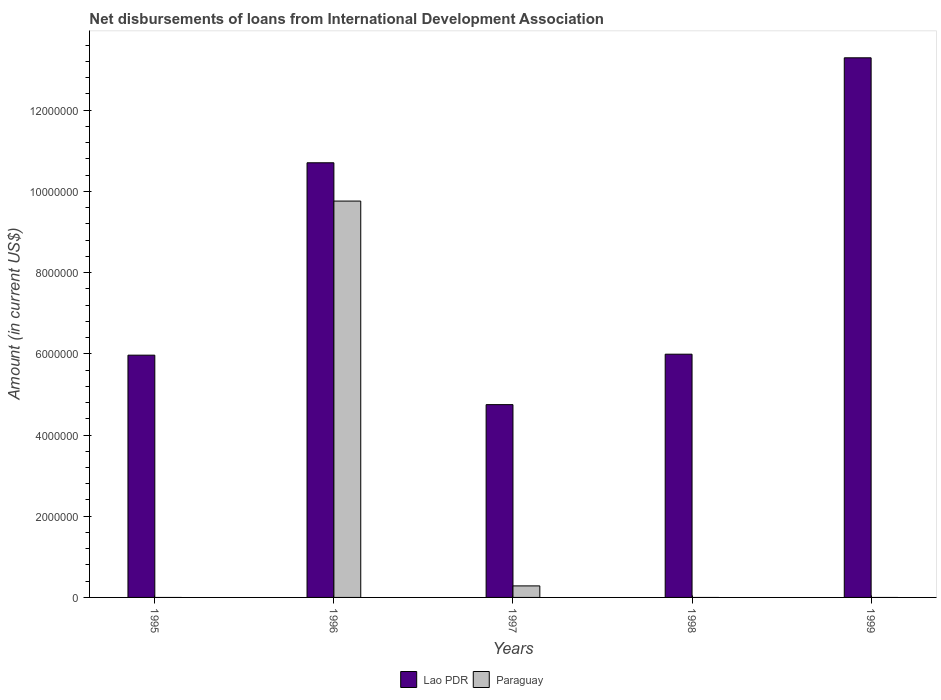How many bars are there on the 4th tick from the right?
Offer a very short reply. 2. Across all years, what is the maximum amount of loans disbursed in Paraguay?
Give a very brief answer. 9.76e+06. Across all years, what is the minimum amount of loans disbursed in Paraguay?
Give a very brief answer. 0. In which year was the amount of loans disbursed in Lao PDR maximum?
Make the answer very short. 1999. What is the total amount of loans disbursed in Paraguay in the graph?
Your answer should be compact. 1.00e+07. What is the difference between the amount of loans disbursed in Lao PDR in 1996 and that in 1998?
Your response must be concise. 4.71e+06. What is the difference between the amount of loans disbursed in Lao PDR in 1996 and the amount of loans disbursed in Paraguay in 1995?
Give a very brief answer. 1.07e+07. What is the average amount of loans disbursed in Paraguay per year?
Keep it short and to the point. 2.01e+06. In the year 1996, what is the difference between the amount of loans disbursed in Lao PDR and amount of loans disbursed in Paraguay?
Offer a terse response. 9.43e+05. In how many years, is the amount of loans disbursed in Paraguay greater than 2000000 US$?
Your answer should be compact. 1. What is the ratio of the amount of loans disbursed in Lao PDR in 1996 to that in 1999?
Ensure brevity in your answer.  0.81. Is the amount of loans disbursed in Paraguay in 1996 less than that in 1997?
Your response must be concise. No. What is the difference between the highest and the second highest amount of loans disbursed in Lao PDR?
Make the answer very short. 2.58e+06. What is the difference between the highest and the lowest amount of loans disbursed in Paraguay?
Provide a short and direct response. 9.76e+06. In how many years, is the amount of loans disbursed in Lao PDR greater than the average amount of loans disbursed in Lao PDR taken over all years?
Give a very brief answer. 2. Is the sum of the amount of loans disbursed in Paraguay in 1996 and 1997 greater than the maximum amount of loans disbursed in Lao PDR across all years?
Your response must be concise. No. How many bars are there?
Provide a short and direct response. 7. How many years are there in the graph?
Provide a succinct answer. 5. Are the values on the major ticks of Y-axis written in scientific E-notation?
Give a very brief answer. No. Does the graph contain any zero values?
Make the answer very short. Yes. How many legend labels are there?
Make the answer very short. 2. How are the legend labels stacked?
Offer a very short reply. Horizontal. What is the title of the graph?
Ensure brevity in your answer.  Net disbursements of loans from International Development Association. Does "Azerbaijan" appear as one of the legend labels in the graph?
Give a very brief answer. No. What is the Amount (in current US$) in Lao PDR in 1995?
Your answer should be compact. 5.97e+06. What is the Amount (in current US$) in Paraguay in 1995?
Your answer should be very brief. 0. What is the Amount (in current US$) in Lao PDR in 1996?
Your response must be concise. 1.07e+07. What is the Amount (in current US$) of Paraguay in 1996?
Your answer should be very brief. 9.76e+06. What is the Amount (in current US$) in Lao PDR in 1997?
Give a very brief answer. 4.75e+06. What is the Amount (in current US$) of Paraguay in 1997?
Keep it short and to the point. 2.84e+05. What is the Amount (in current US$) in Lao PDR in 1998?
Provide a short and direct response. 5.99e+06. What is the Amount (in current US$) in Paraguay in 1998?
Keep it short and to the point. 0. What is the Amount (in current US$) of Lao PDR in 1999?
Provide a short and direct response. 1.33e+07. What is the Amount (in current US$) of Paraguay in 1999?
Your response must be concise. 0. Across all years, what is the maximum Amount (in current US$) in Lao PDR?
Offer a very short reply. 1.33e+07. Across all years, what is the maximum Amount (in current US$) of Paraguay?
Make the answer very short. 9.76e+06. Across all years, what is the minimum Amount (in current US$) of Lao PDR?
Ensure brevity in your answer.  4.75e+06. Across all years, what is the minimum Amount (in current US$) in Paraguay?
Offer a terse response. 0. What is the total Amount (in current US$) of Lao PDR in the graph?
Your answer should be very brief. 4.07e+07. What is the total Amount (in current US$) in Paraguay in the graph?
Keep it short and to the point. 1.00e+07. What is the difference between the Amount (in current US$) of Lao PDR in 1995 and that in 1996?
Offer a very short reply. -4.74e+06. What is the difference between the Amount (in current US$) of Lao PDR in 1995 and that in 1997?
Your response must be concise. 1.22e+06. What is the difference between the Amount (in current US$) in Lao PDR in 1995 and that in 1998?
Your answer should be compact. -2.40e+04. What is the difference between the Amount (in current US$) of Lao PDR in 1995 and that in 1999?
Your answer should be compact. -7.32e+06. What is the difference between the Amount (in current US$) in Lao PDR in 1996 and that in 1997?
Provide a succinct answer. 5.96e+06. What is the difference between the Amount (in current US$) of Paraguay in 1996 and that in 1997?
Provide a succinct answer. 9.48e+06. What is the difference between the Amount (in current US$) in Lao PDR in 1996 and that in 1998?
Your response must be concise. 4.71e+06. What is the difference between the Amount (in current US$) in Lao PDR in 1996 and that in 1999?
Ensure brevity in your answer.  -2.58e+06. What is the difference between the Amount (in current US$) in Lao PDR in 1997 and that in 1998?
Offer a terse response. -1.24e+06. What is the difference between the Amount (in current US$) of Lao PDR in 1997 and that in 1999?
Your answer should be very brief. -8.54e+06. What is the difference between the Amount (in current US$) in Lao PDR in 1998 and that in 1999?
Ensure brevity in your answer.  -7.30e+06. What is the difference between the Amount (in current US$) of Lao PDR in 1995 and the Amount (in current US$) of Paraguay in 1996?
Offer a very short reply. -3.80e+06. What is the difference between the Amount (in current US$) of Lao PDR in 1995 and the Amount (in current US$) of Paraguay in 1997?
Provide a succinct answer. 5.68e+06. What is the difference between the Amount (in current US$) in Lao PDR in 1996 and the Amount (in current US$) in Paraguay in 1997?
Give a very brief answer. 1.04e+07. What is the average Amount (in current US$) of Lao PDR per year?
Make the answer very short. 8.14e+06. What is the average Amount (in current US$) in Paraguay per year?
Keep it short and to the point. 2.01e+06. In the year 1996, what is the difference between the Amount (in current US$) of Lao PDR and Amount (in current US$) of Paraguay?
Your response must be concise. 9.43e+05. In the year 1997, what is the difference between the Amount (in current US$) of Lao PDR and Amount (in current US$) of Paraguay?
Offer a very short reply. 4.46e+06. What is the ratio of the Amount (in current US$) of Lao PDR in 1995 to that in 1996?
Offer a terse response. 0.56. What is the ratio of the Amount (in current US$) of Lao PDR in 1995 to that in 1997?
Provide a short and direct response. 1.26. What is the ratio of the Amount (in current US$) in Lao PDR in 1995 to that in 1999?
Keep it short and to the point. 0.45. What is the ratio of the Amount (in current US$) of Lao PDR in 1996 to that in 1997?
Your answer should be compact. 2.25. What is the ratio of the Amount (in current US$) of Paraguay in 1996 to that in 1997?
Your answer should be very brief. 34.37. What is the ratio of the Amount (in current US$) in Lao PDR in 1996 to that in 1998?
Provide a succinct answer. 1.79. What is the ratio of the Amount (in current US$) in Lao PDR in 1996 to that in 1999?
Make the answer very short. 0.81. What is the ratio of the Amount (in current US$) of Lao PDR in 1997 to that in 1998?
Make the answer very short. 0.79. What is the ratio of the Amount (in current US$) in Lao PDR in 1997 to that in 1999?
Ensure brevity in your answer.  0.36. What is the ratio of the Amount (in current US$) of Lao PDR in 1998 to that in 1999?
Keep it short and to the point. 0.45. What is the difference between the highest and the second highest Amount (in current US$) of Lao PDR?
Provide a succinct answer. 2.58e+06. What is the difference between the highest and the lowest Amount (in current US$) of Lao PDR?
Your response must be concise. 8.54e+06. What is the difference between the highest and the lowest Amount (in current US$) in Paraguay?
Your answer should be compact. 9.76e+06. 